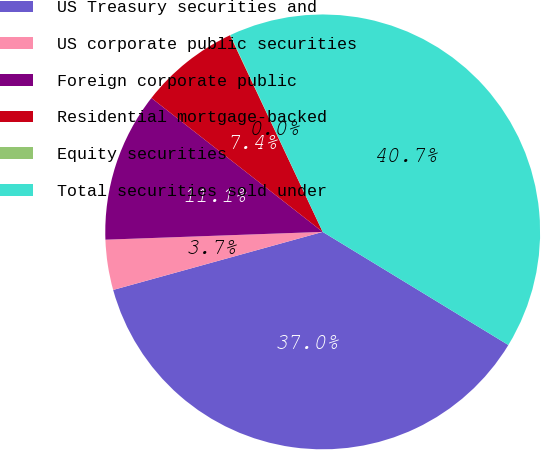Convert chart to OTSL. <chart><loc_0><loc_0><loc_500><loc_500><pie_chart><fcel>US Treasury securities and<fcel>US corporate public securities<fcel>Foreign corporate public<fcel>Residential mortgage-backed<fcel>Equity securities<fcel>Total securities sold under<nl><fcel>36.99%<fcel>3.73%<fcel>11.13%<fcel>7.43%<fcel>0.03%<fcel>40.69%<nl></chart> 